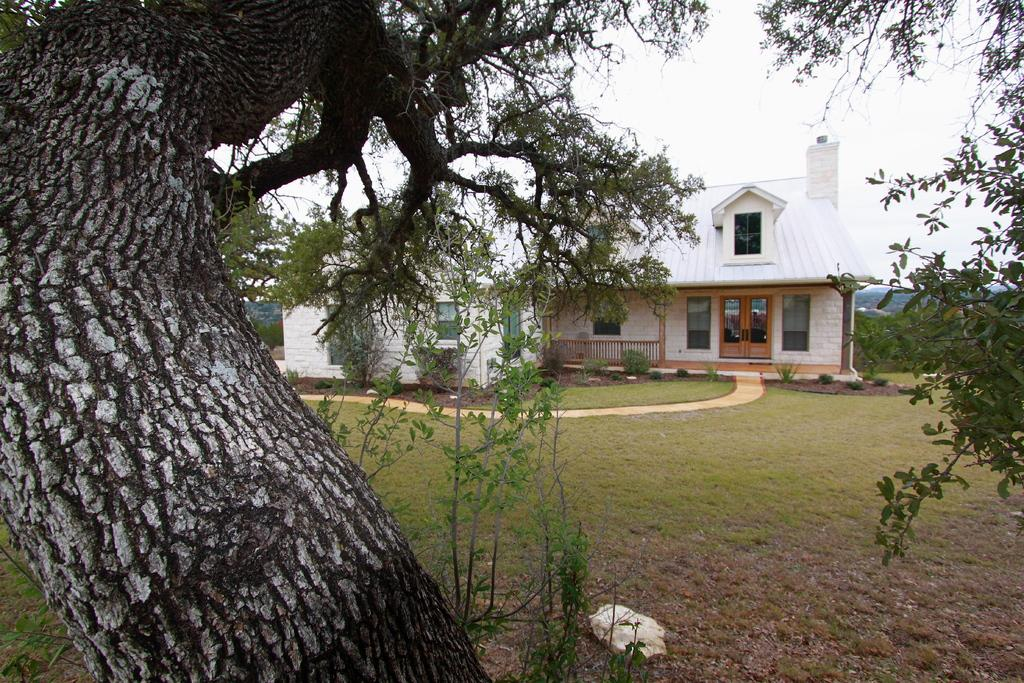What type of structure is visible in the image? There is a house in the image. What type of vegetation is present in the image? There is grass, trees, and plants in the image. What can be seen in the background of the image? The sky is visible in the background of the image. What memory does the donkey have of the experience in the image? There is no donkey present in the image, so it is not possible to determine any memories or experiences related to the image. 